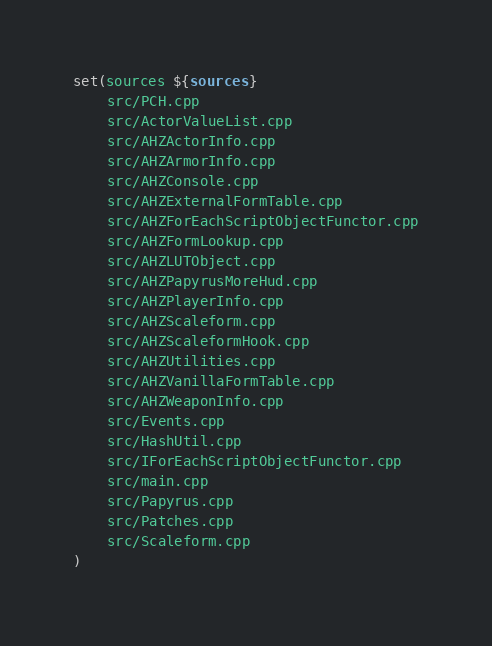<code> <loc_0><loc_0><loc_500><loc_500><_CMake_>set(sources ${sources}
    src/PCH.cpp
    src/ActorValueList.cpp
    src/AHZActorInfo.cpp
    src/AHZArmorInfo.cpp
    src/AHZConsole.cpp
    src/AHZExternalFormTable.cpp   
    src/AHZForEachScriptObjectFunctor.cpp
    src/AHZFormLookup.cpp
    src/AHZLUTObject.cpp
    src/AHZPapyrusMoreHud.cpp      
    src/AHZPlayerInfo.cpp
    src/AHZScaleform.cpp
    src/AHZScaleformHook.cpp       
    src/AHZUtilities.cpp
    src/AHZVanillaFormTable.cpp    
    src/AHZWeaponInfo.cpp
    src/Events.cpp
    src/HashUtil.cpp
    src/IForEachScriptObjectFunctor.cpp
    src/main.cpp
    src/Papyrus.cpp
    src/Patches.cpp
    src/Scaleform.cpp
)</code> 